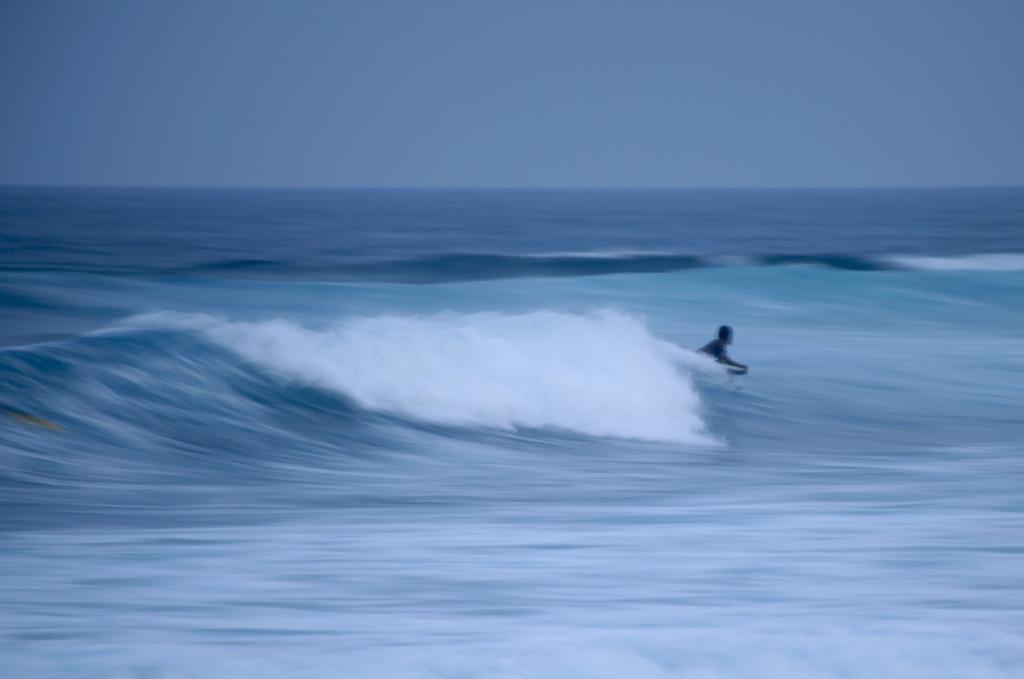What is the person in the image doing? The person is surfing on a surfing board. What is the person surfing on? The person is surfing on ocean tide. What can be seen in the background of the image? There is an ocean and the sky visible in the background of the image. What is the weight of the argument between the person and the ocean in the image? There is no argument present in the image, and therefore no weight can be assigned to it. 